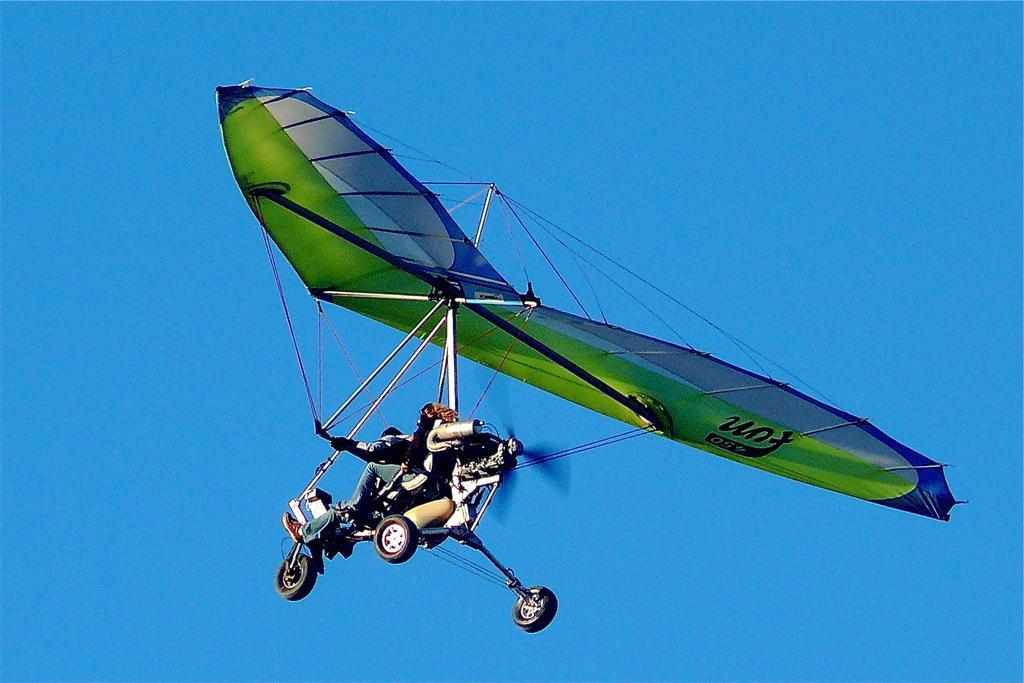In one or two sentences, can you explain what this image depicts? In this picture we can see green color ultralight aviation flying in the sky. 